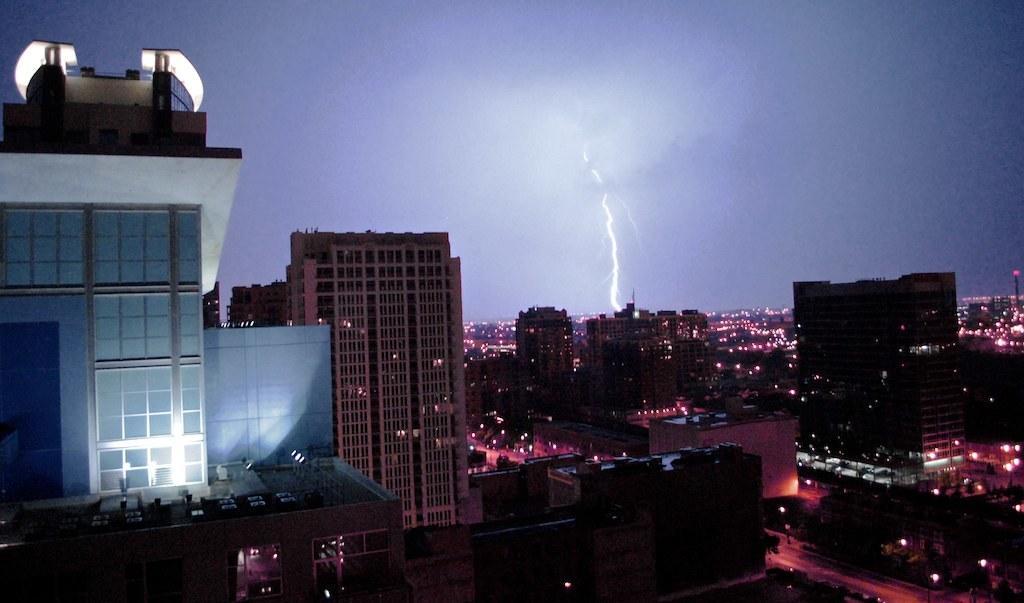How would you summarize this image in a sentence or two? Here we can see buildings with glass windows. Far there is a thunder and lights. 